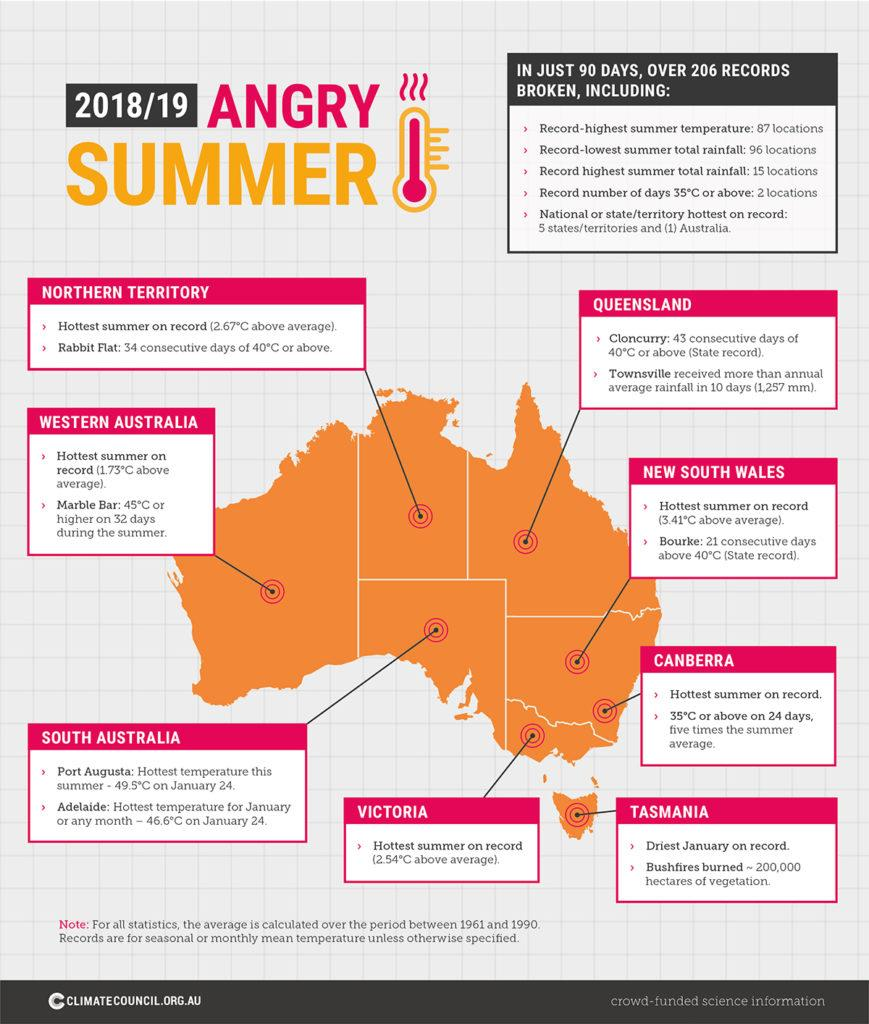Give some essential details in this illustration. The hottest summer was recorded as 2.54 above the average temperature in Victoria. Western Australia experienced an average summer in 2019, with temperatures falling within the normal range. Tasmania had the driest January of all places. The map of Australia is usually depicted in shades of orange. However, there may be instances where it appears pink, depending on the design and color scheme used by the creator. In general, orange is the more prevalent color used to represent Australia on maps. The summer of 3.41 was above average in New South Wales. 